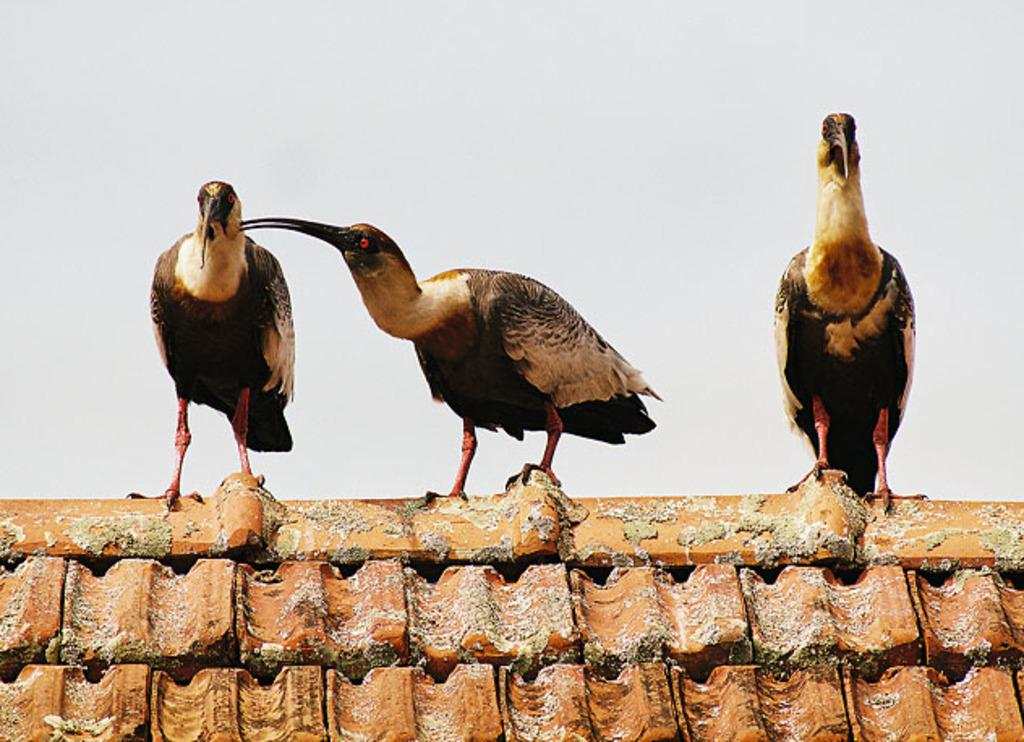What is located on the top of the house in the image? There are birds on the top of the house in the image. What can be seen in the background of the image? The sky is visible in the background of the image. What is the tendency of the card to affect the birds' behavior in the image? There is no card present in the image, so it cannot affect the birds' behavior. How many toes can be seen on the birds in the image? The image does not show the birds' toes, so it is not possible to determine the number of toes. 